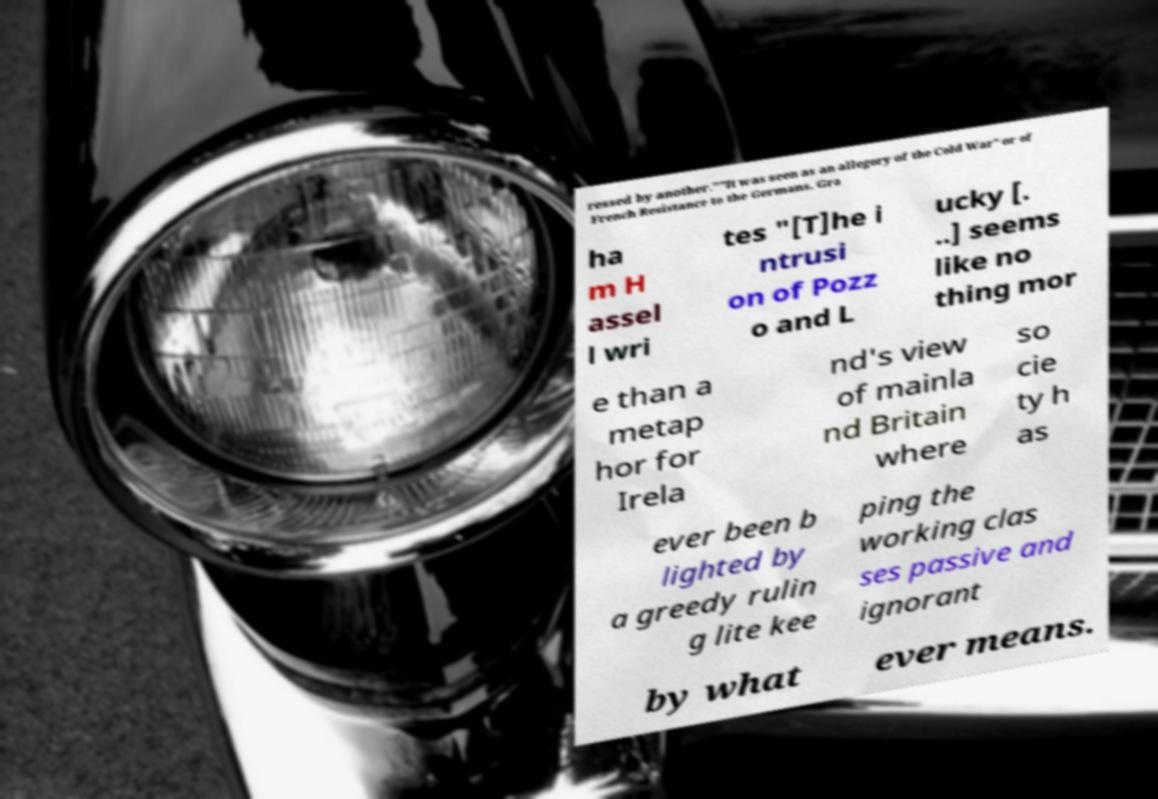There's text embedded in this image that I need extracted. Can you transcribe it verbatim? ressed by another.""It was seen as an allegory of the Cold War" or of French Resistance to the Germans. Gra ha m H assel l wri tes "[T]he i ntrusi on of Pozz o and L ucky [. ..] seems like no thing mor e than a metap hor for Irela nd's view of mainla nd Britain where so cie ty h as ever been b lighted by a greedy rulin g lite kee ping the working clas ses passive and ignorant by what ever means. 